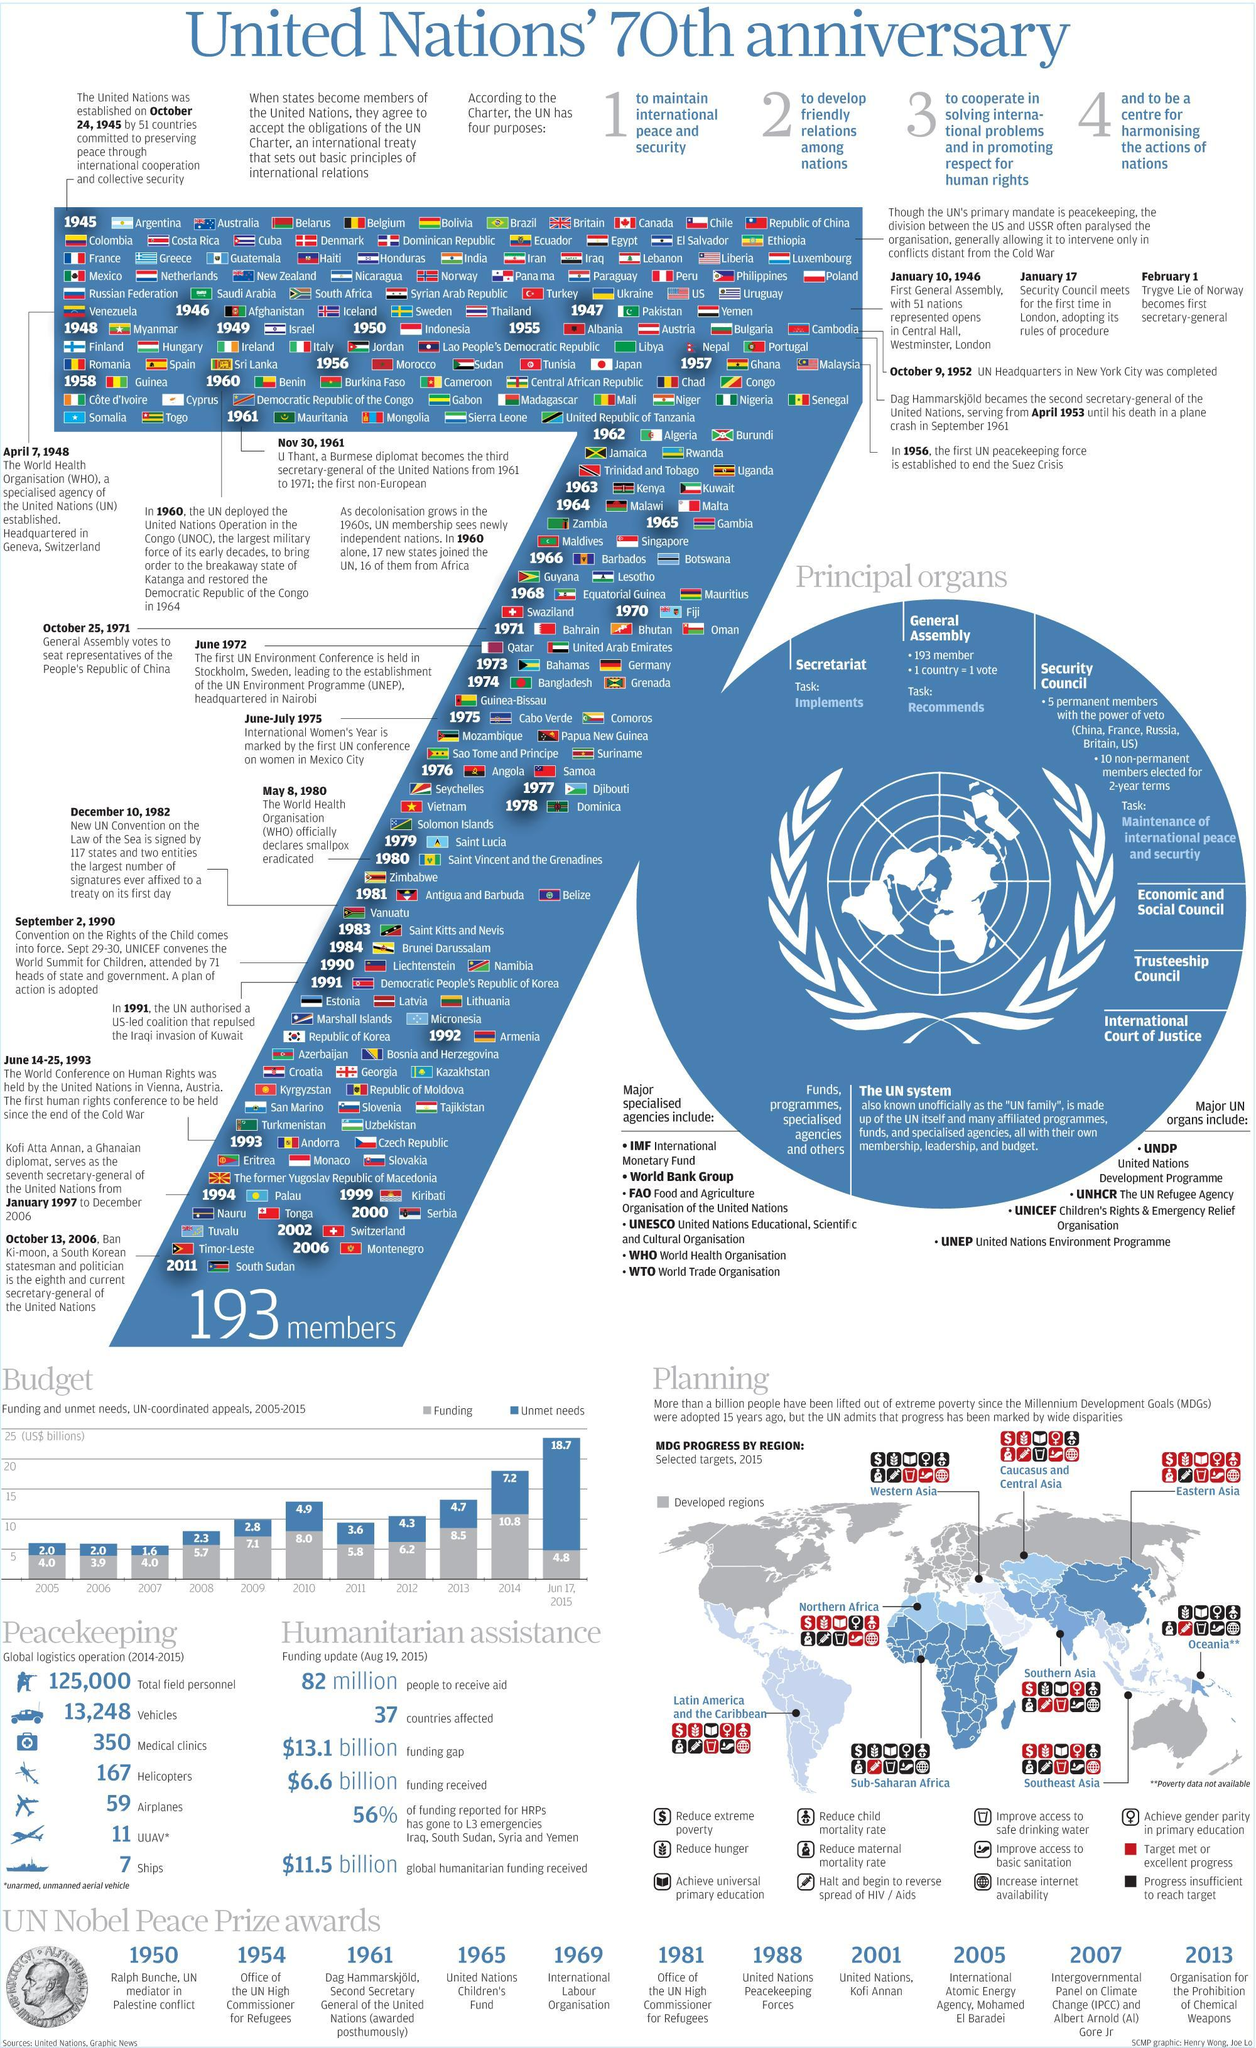Which region has the lowest number of MDG target met ?
Answer the question with a short phrase. Sub-Saharan Africa How many principal organs does the UN have? 6 What is total number of airplanes, helicopters and UUAV deployed for global logistics operation? 237 When did the first secretary general assume office ? February 1, 1946 How many nations do not have a membership at UN ? 2 Which region shows the highest number target met or MDG progress? Eastern Asia Which year shows the third highest unmet needs in the budget? 2010 Which categories does Caucasus and Central Asia needs to improve still? Primary education, child mortality, drinking water Which year did United Nations come into existence? 1945 Which two years according to the budget has the second lowest funding ? 2005, 2007 